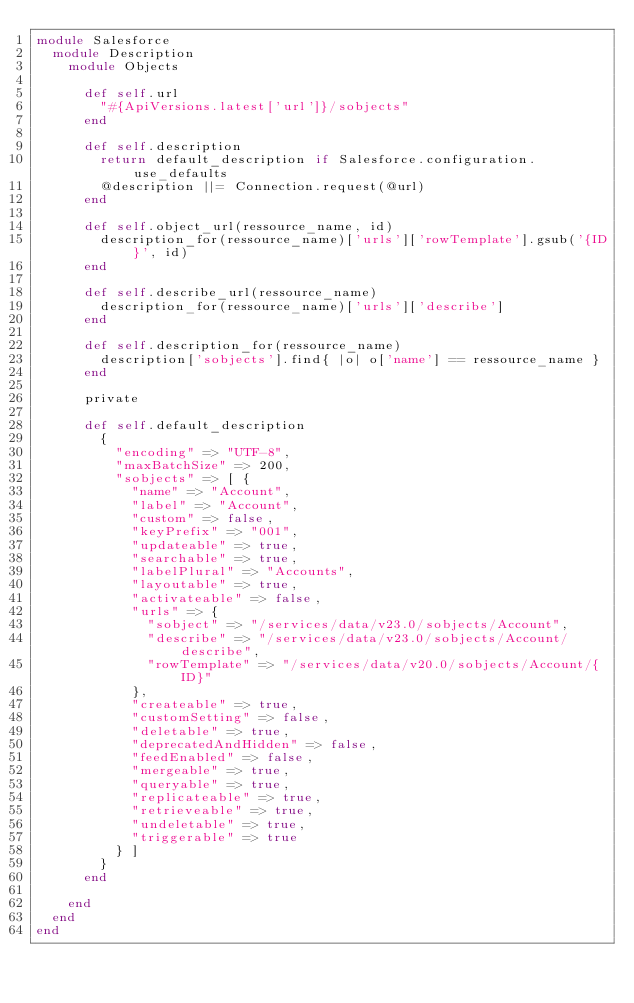<code> <loc_0><loc_0><loc_500><loc_500><_Ruby_>module Salesforce
  module Description
    module Objects

      def self.url
        "#{ApiVersions.latest['url']}/sobjects"
      end

      def self.description
        return default_description if Salesforce.configuration.use_defaults
        @description ||= Connection.request(@url)
      end

      def self.object_url(ressource_name, id)
        description_for(ressource_name)['urls']['rowTemplate'].gsub('{ID}', id)
      end

      def self.describe_url(ressource_name)
        description_for(ressource_name)['urls']['describe']
      end

      def self.description_for(ressource_name)
        description['sobjects'].find{ |o| o['name'] == ressource_name }
      end

      private

      def self.default_description
        {
          "encoding" => "UTF-8",
          "maxBatchSize" => 200,
          "sobjects" => [ {
            "name" => "Account",
            "label" => "Account",
            "custom" => false,
            "keyPrefix" => "001",
            "updateable" => true,
            "searchable" => true,
            "labelPlural" => "Accounts",
            "layoutable" => true,
            "activateable" => false,
            "urls" => {
              "sobject" => "/services/data/v23.0/sobjects/Account",
              "describe" => "/services/data/v23.0/sobjects/Account/describe",
              "rowTemplate" => "/services/data/v20.0/sobjects/Account/{ID}"
            },
            "createable" => true,
            "customSetting" => false,
            "deletable" => true,
            "deprecatedAndHidden" => false,
            "feedEnabled" => false,
            "mergeable" => true,
            "queryable" => true,
            "replicateable" => true,
            "retrieveable" => true,
            "undeletable" => true,
            "triggerable" => true
          } ]
        }
      end

    end
  end
end
</code> 